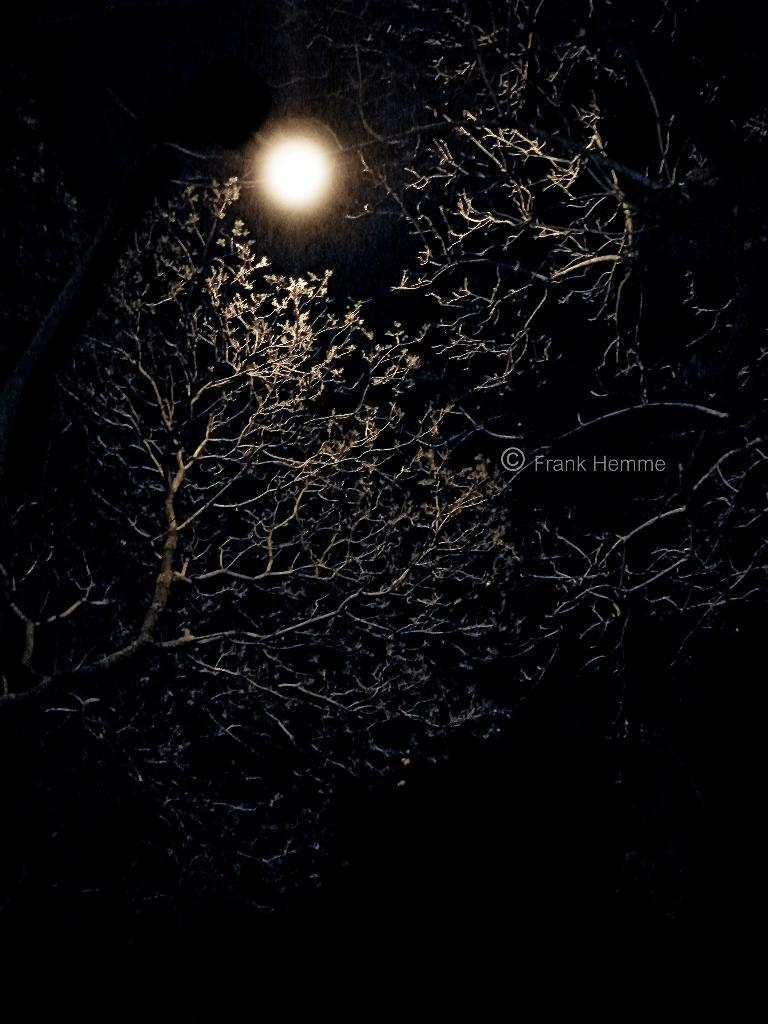What type of vegetation can be seen in the image? There are trees in the image. What celestial body is visible in the image? The moon is visible in the image. Is there any text or logo present in the image? Yes, there is a watermark in the image. How would you describe the overall lighting in the image? The image is dark. Can you tell me how many snakes are slithering through the trees in the image? There are no snakes present in the image; it features trees and the moon. What type of feast is being held under the trees in the image? There is no feast or gathering of people present in the image; it is a scene of trees and the moon. 